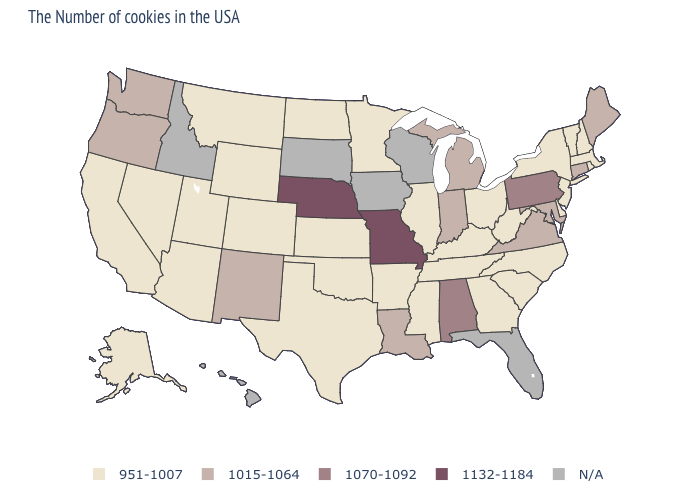Name the states that have a value in the range 951-1007?
Quick response, please. Massachusetts, Rhode Island, New Hampshire, Vermont, New York, New Jersey, Delaware, North Carolina, South Carolina, West Virginia, Ohio, Georgia, Kentucky, Tennessee, Illinois, Mississippi, Arkansas, Minnesota, Kansas, Oklahoma, Texas, North Dakota, Wyoming, Colorado, Utah, Montana, Arizona, Nevada, California, Alaska. Which states have the lowest value in the USA?
Concise answer only. Massachusetts, Rhode Island, New Hampshire, Vermont, New York, New Jersey, Delaware, North Carolina, South Carolina, West Virginia, Ohio, Georgia, Kentucky, Tennessee, Illinois, Mississippi, Arkansas, Minnesota, Kansas, Oklahoma, Texas, North Dakota, Wyoming, Colorado, Utah, Montana, Arizona, Nevada, California, Alaska. How many symbols are there in the legend?
Concise answer only. 5. Name the states that have a value in the range 951-1007?
Short answer required. Massachusetts, Rhode Island, New Hampshire, Vermont, New York, New Jersey, Delaware, North Carolina, South Carolina, West Virginia, Ohio, Georgia, Kentucky, Tennessee, Illinois, Mississippi, Arkansas, Minnesota, Kansas, Oklahoma, Texas, North Dakota, Wyoming, Colorado, Utah, Montana, Arizona, Nevada, California, Alaska. Which states hav the highest value in the West?
Concise answer only. New Mexico, Washington, Oregon. What is the value of Arizona?
Be succinct. 951-1007. Name the states that have a value in the range 951-1007?
Keep it brief. Massachusetts, Rhode Island, New Hampshire, Vermont, New York, New Jersey, Delaware, North Carolina, South Carolina, West Virginia, Ohio, Georgia, Kentucky, Tennessee, Illinois, Mississippi, Arkansas, Minnesota, Kansas, Oklahoma, Texas, North Dakota, Wyoming, Colorado, Utah, Montana, Arizona, Nevada, California, Alaska. Name the states that have a value in the range N/A?
Quick response, please. Florida, Wisconsin, Iowa, South Dakota, Idaho, Hawaii. What is the value of Maine?
Be succinct. 1015-1064. Does Missouri have the highest value in the USA?
Short answer required. Yes. What is the lowest value in the USA?
Keep it brief. 951-1007. Name the states that have a value in the range N/A?
Concise answer only. Florida, Wisconsin, Iowa, South Dakota, Idaho, Hawaii. Name the states that have a value in the range 1132-1184?
Short answer required. Missouri, Nebraska. Does Connecticut have the lowest value in the USA?
Be succinct. No. 